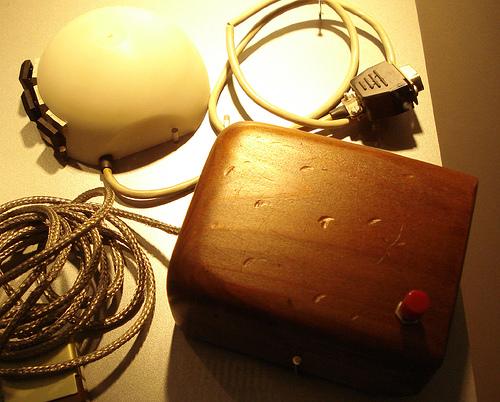What is the light source?
Short answer required. Lamp. What is this equipment?
Short answer required. Computer. What are the chords for?
Be succinct. Computer. 